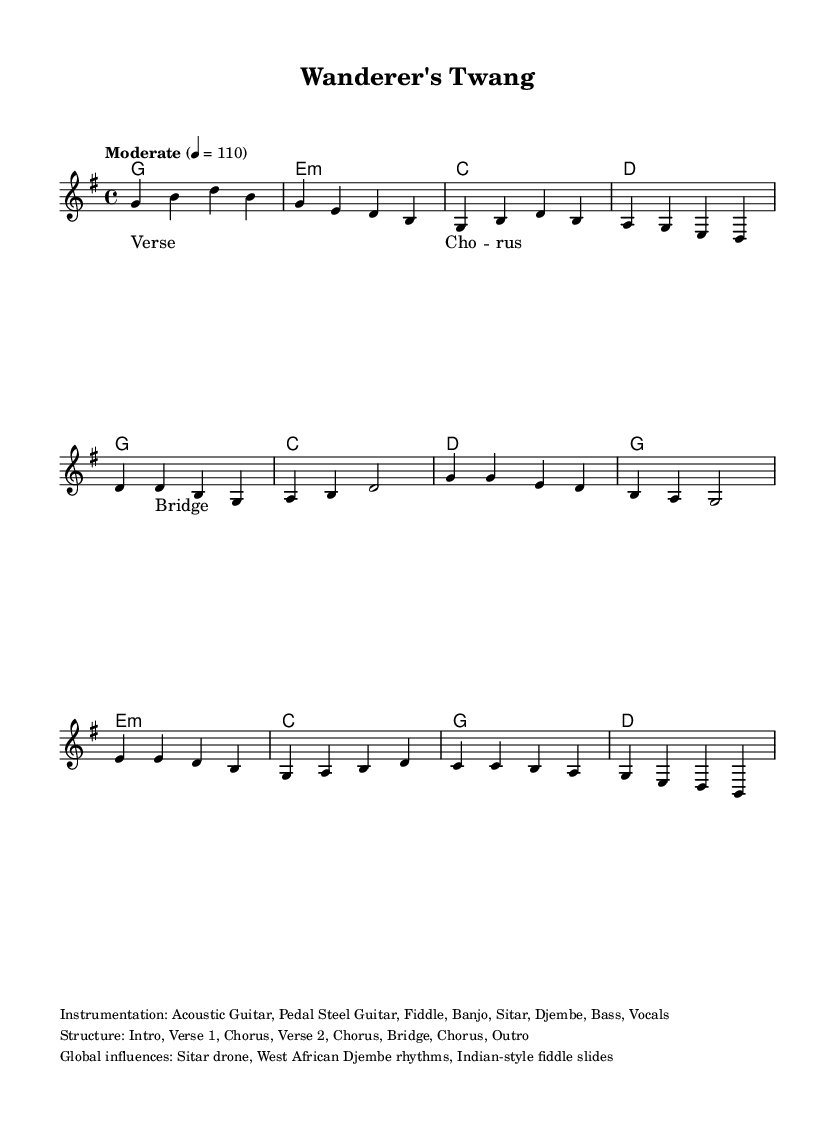What is the key signature of this music? The key signature is indicated at the beginning of the score, and it shows one sharp, which signifies that the piece is in G major.
Answer: G major What is the time signature of this music? The time signature is shown as a fraction at the beginning of the score, which indicates there are four beats per measure and a quarter note gets one beat, represented as 4/4.
Answer: 4/4 What is the tempo marking for this piece? The tempo marking is included at the beginning of the score next to the time signature, stating "Moderate" with a metronome marking of 110 beats per minute, providing a clear indication of the desired speed.
Answer: Moderate 4 = 110 How many sections are in the structure of the music? The structure is listed in the markup section, and it details the parts of the music: Intro, Verse 1, Chorus, Verse 2, Chorus, Bridge, Chorus, and Outro, leading to a total of 8 sections.
Answer: 8 What instruments are used in this piece? The instrumentation is provided in the markup section, listing Acoustic Guitar, Pedal Steel Guitar, Fiddle, Banjo, Sitar, Djembe, Bass, and Vocals, highlighting the blend of traditional and global influences.
Answer: Acoustic Guitar, Pedal Steel Guitar, Fiddle, Banjo, Sitar, Djembe, Bass, Vocals What global influences are present in this music? The global influences are specified in the markup section, citing the Sitar drone, West African Djembe rhythms, and Indian-style fiddle slides, suggesting a rich fusion of cultural elements within the country music genre.
Answer: Sitar drone, West African Djembe rhythms, Indian-style fiddle slides What type of musical form does this song predominantly follow? The form is inferred from the structure listed in the markup section, showing a clear repetition of sections and a typical verse-chorus pattern commonly found in country music, highlighting its structured nature.
Answer: Verse-Chorus 